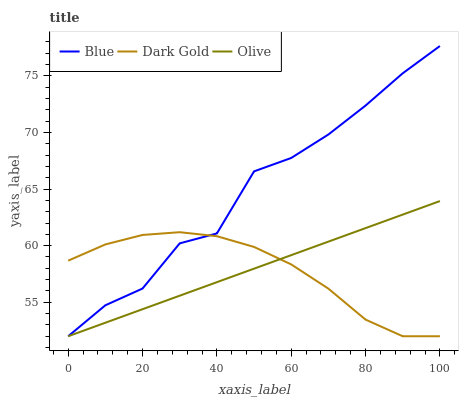Does Dark Gold have the minimum area under the curve?
Answer yes or no. Yes. Does Blue have the maximum area under the curve?
Answer yes or no. Yes. Does Olive have the minimum area under the curve?
Answer yes or no. No. Does Olive have the maximum area under the curve?
Answer yes or no. No. Is Olive the smoothest?
Answer yes or no. Yes. Is Blue the roughest?
Answer yes or no. Yes. Is Dark Gold the smoothest?
Answer yes or no. No. Is Dark Gold the roughest?
Answer yes or no. No. Does Blue have the lowest value?
Answer yes or no. Yes. Does Blue have the highest value?
Answer yes or no. Yes. Does Olive have the highest value?
Answer yes or no. No. Does Dark Gold intersect Blue?
Answer yes or no. Yes. Is Dark Gold less than Blue?
Answer yes or no. No. Is Dark Gold greater than Blue?
Answer yes or no. No. 